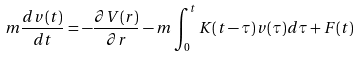Convert formula to latex. <formula><loc_0><loc_0><loc_500><loc_500>m \frac { d { v } ( t ) } { d t } = - \frac { \partial V ( r ) } { \partial { r } } - m \int _ { 0 } ^ { t } K ( t - \tau ) { v } ( \tau ) d \tau + { F } ( t )</formula> 